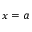Convert formula to latex. <formula><loc_0><loc_0><loc_500><loc_500>x = a</formula> 